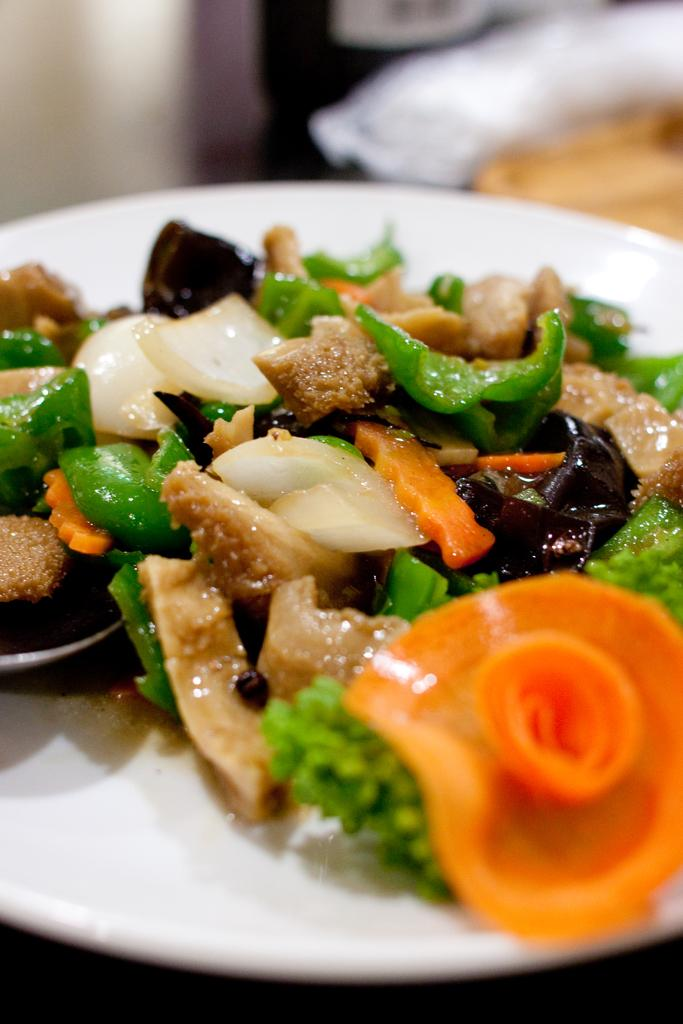What is on the plate in the image? There are food items on a plate in the image. Can you describe the background of the image? The background of the image is blurred. What type of square pattern can be seen on the son's shirt in the image? There is no son or shirt present in the image, so there is no square pattern to describe. 